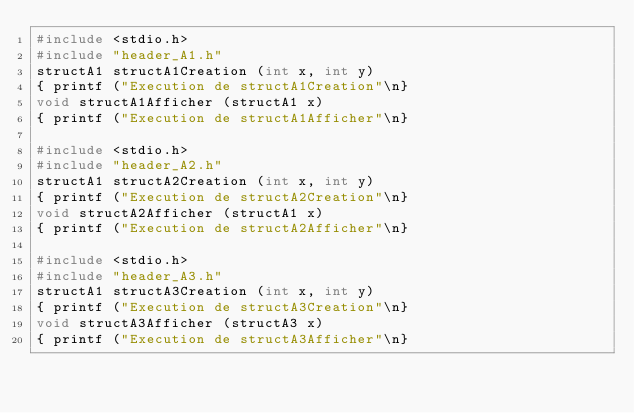<code> <loc_0><loc_0><loc_500><loc_500><_C_>#include <stdio.h>
#include "header_A1.h"
structA1 structA1Creation (int x, int y)
{ printf ("Execution de structA1Creation"\n}
void structA1Afficher (structA1 x)
{ printf ("Execution de structA1Afficher"\n}

#include <stdio.h>
#include "header_A2.h"
structA1 structA2Creation (int x, int y)
{ printf ("Execution de structA2Creation"\n}
void structA2Afficher (structA1 x)
{ printf ("Execution de structA2Afficher"\n}

#include <stdio.h>
#include "header_A3.h"
structA1 structA3Creation (int x, int y)
{ printf ("Execution de structA3Creation"\n}
void structA3Afficher (structA3 x)
{ printf ("Execution de structA3Afficher"\n}

</code> 